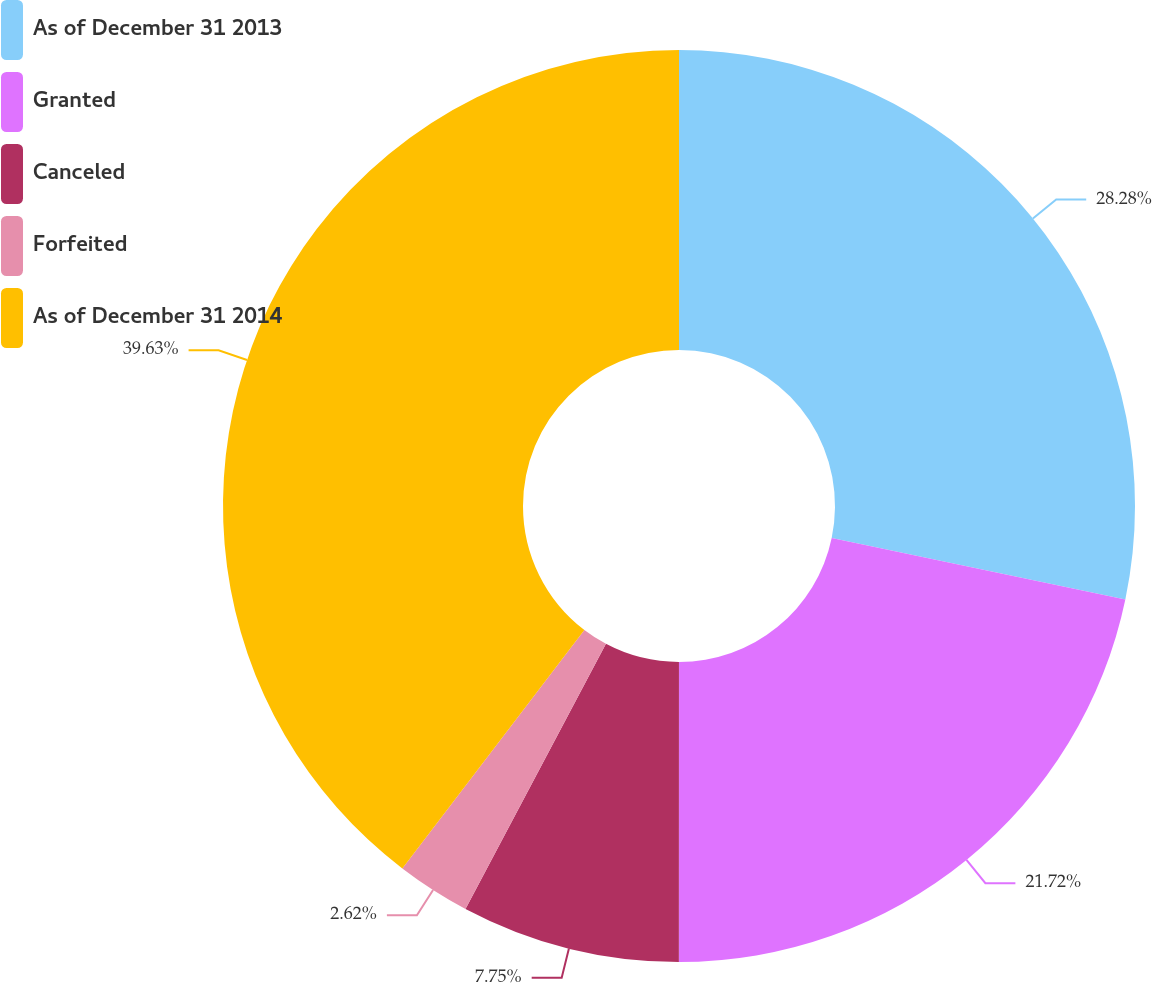<chart> <loc_0><loc_0><loc_500><loc_500><pie_chart><fcel>As of December 31 2013<fcel>Granted<fcel>Canceled<fcel>Forfeited<fcel>As of December 31 2014<nl><fcel>28.28%<fcel>21.72%<fcel>7.75%<fcel>2.62%<fcel>39.62%<nl></chart> 